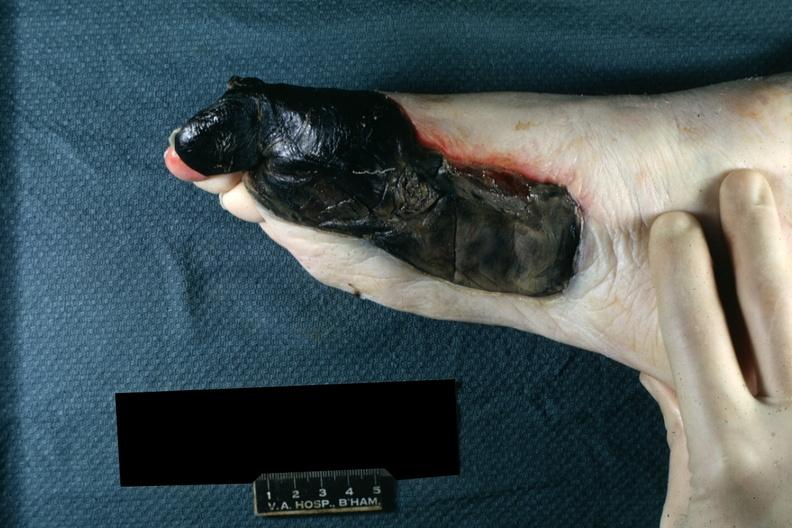what are present?
Answer the question using a single word or phrase. Extremities 